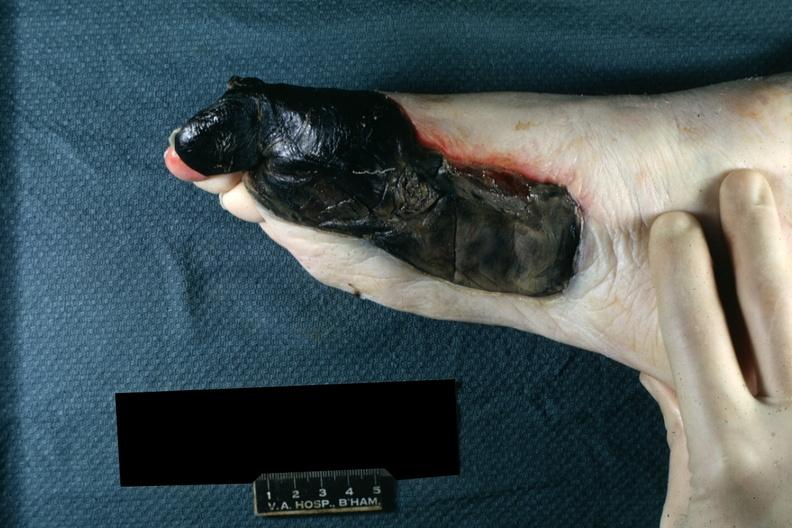what are present?
Answer the question using a single word or phrase. Extremities 